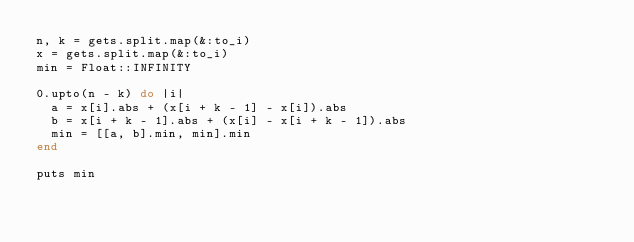<code> <loc_0><loc_0><loc_500><loc_500><_Ruby_>n, k = gets.split.map(&:to_i)
x = gets.split.map(&:to_i)
min = Float::INFINITY

0.upto(n - k) do |i|
  a = x[i].abs + (x[i + k - 1] - x[i]).abs
  b = x[i + k - 1].abs + (x[i] - x[i + k - 1]).abs
  min = [[a, b].min, min].min
end

puts min</code> 